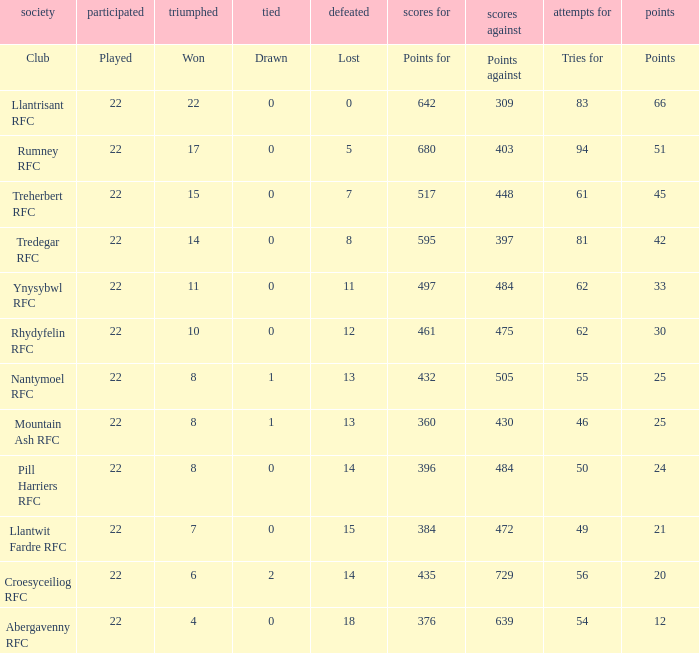For the team that amassed exactly 396 points, how many tries did they score? 50.0. 